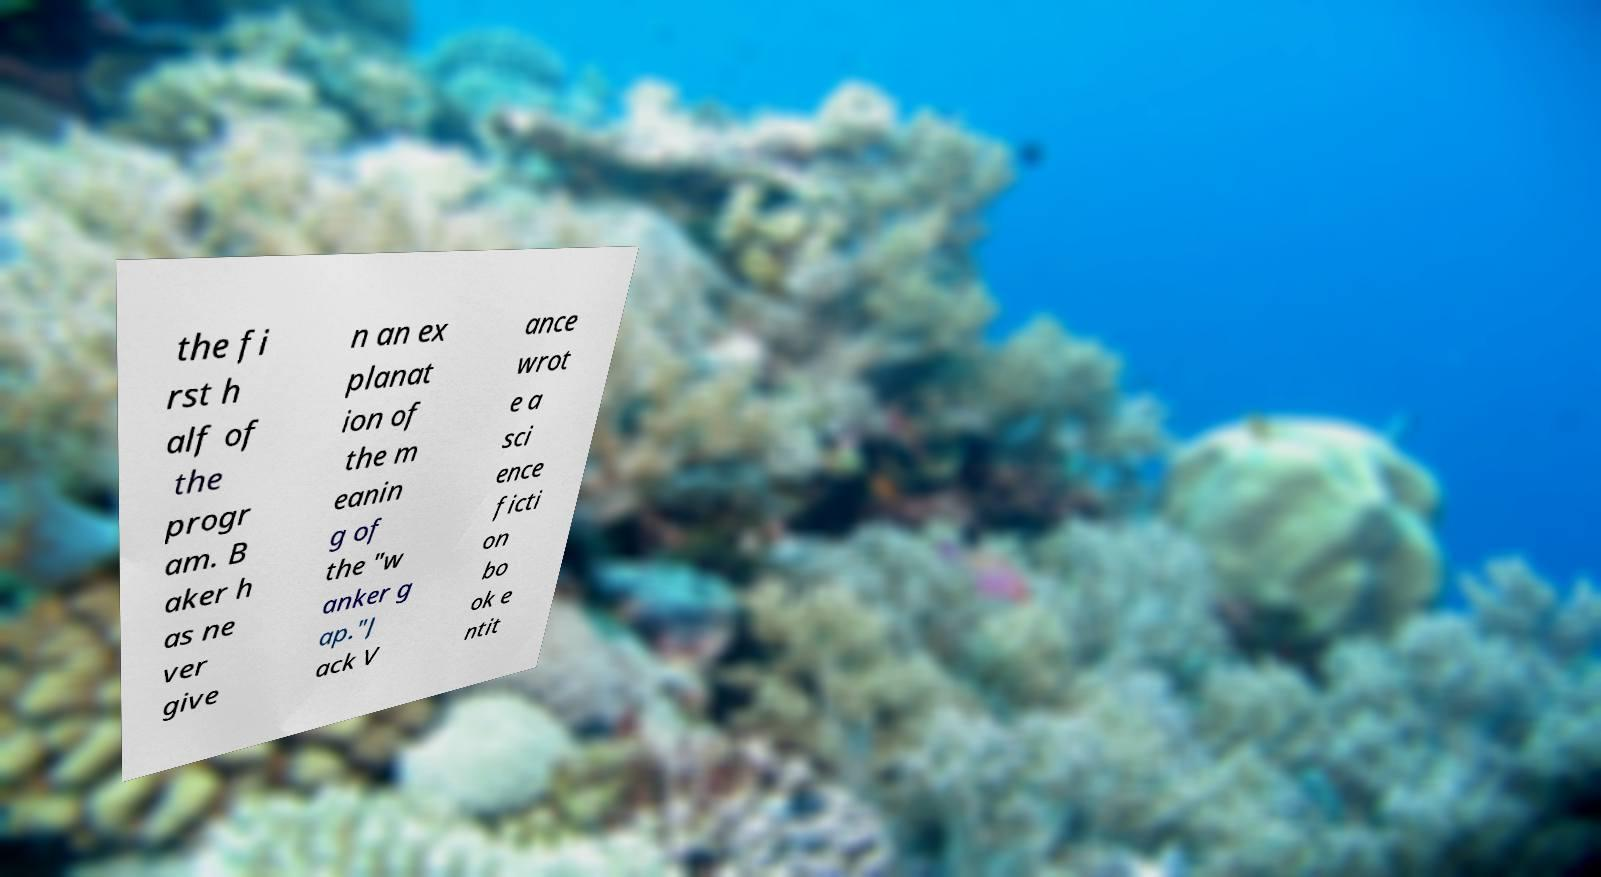Could you extract and type out the text from this image? the fi rst h alf of the progr am. B aker h as ne ver give n an ex planat ion of the m eanin g of the "w anker g ap."J ack V ance wrot e a sci ence ficti on bo ok e ntit 